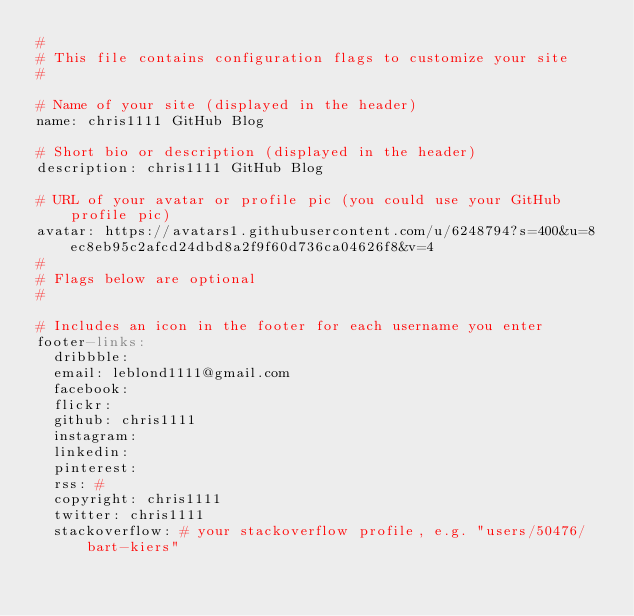<code> <loc_0><loc_0><loc_500><loc_500><_YAML_>#
# This file contains configuration flags to customize your site
#

# Name of your site (displayed in the header)
name: chris1111 GitHub Blog

# Short bio or description (displayed in the header)
description: chris1111 GitHub Blog

# URL of your avatar or profile pic (you could use your GitHub profile pic)
avatar: https://avatars1.githubusercontent.com/u/6248794?s=400&u=8ec8eb95c2afcd24dbd8a2f9f60d736ca04626f8&v=4
#
# Flags below are optional
#

# Includes an icon in the footer for each username you enter
footer-links:
  dribbble:
  email: leblond1111@gmail.com
  facebook:
  flickr:
  github: chris1111
  instagram:
  linkedin:
  pinterest:
  rss: #
  copyright: chris1111
  twitter: chris1111
  stackoverflow: # your stackoverflow profile, e.g. "users/50476/bart-kiers"</code> 